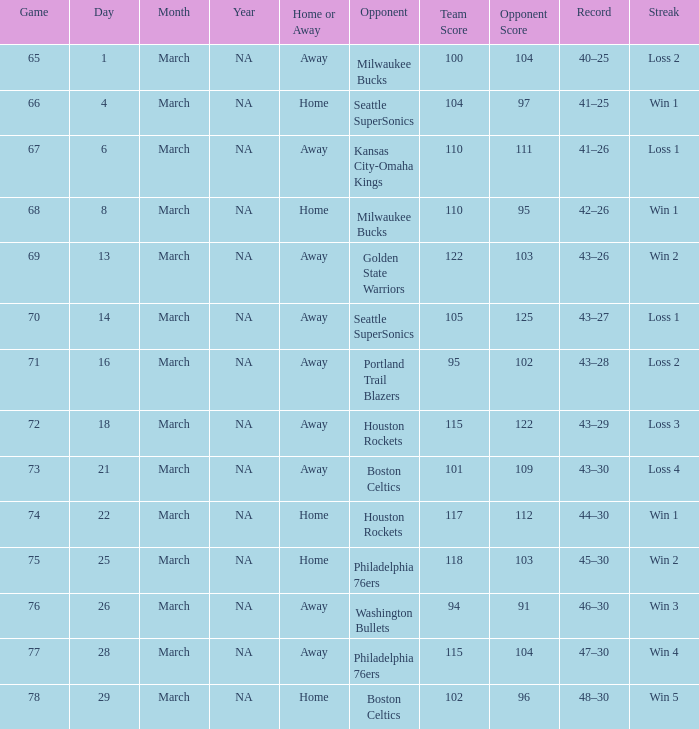What is the lowest Game, when Date is March 21? 73.0. 